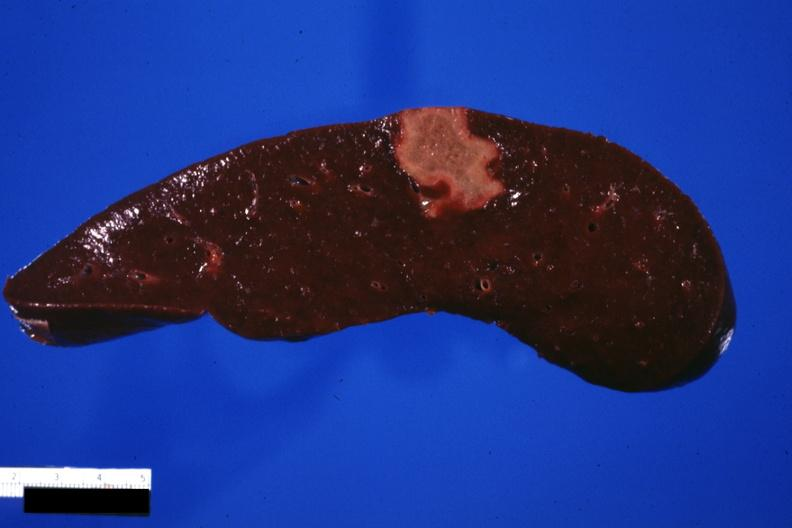what does this image show?
Answer the question using a single word or phrase. Cut surface of spleen with an infarct several days of age excellent photo 